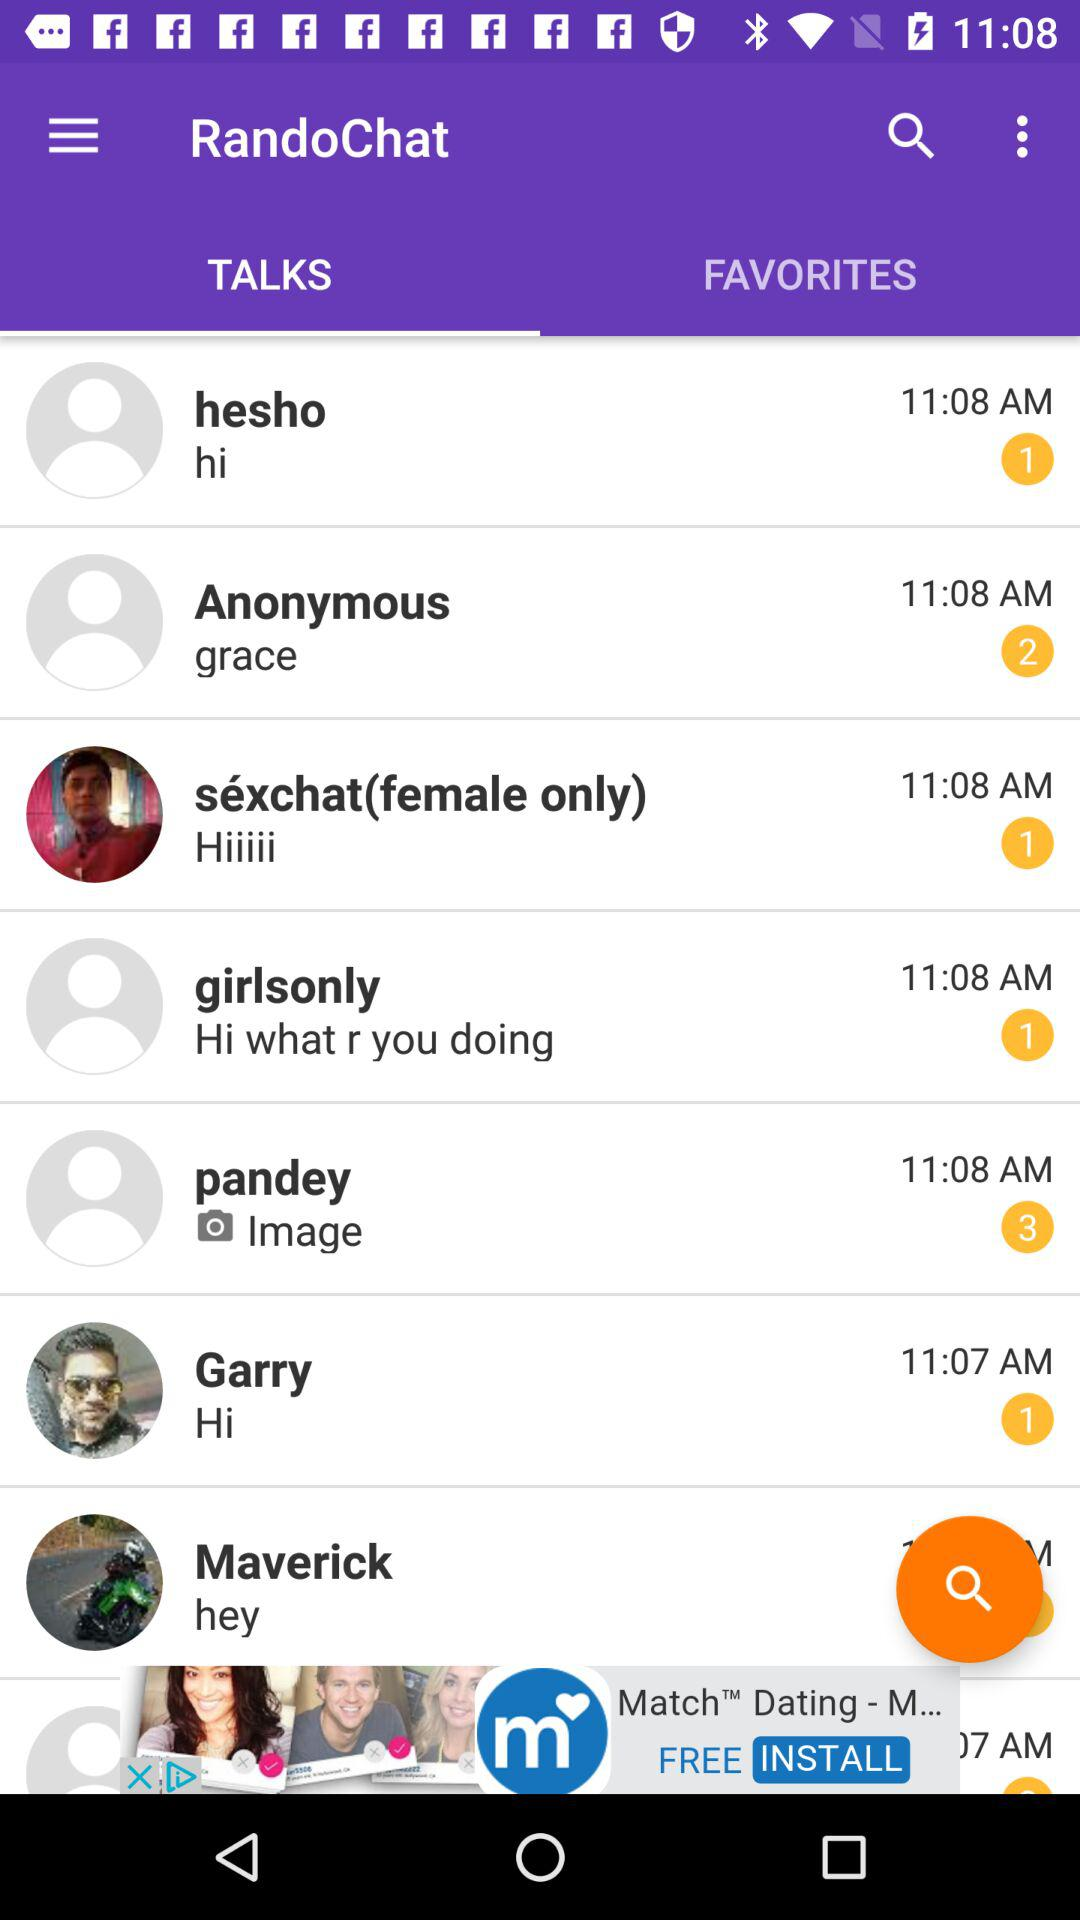At what time was the message received from Hesho? The message was received at 11:08 AM. 